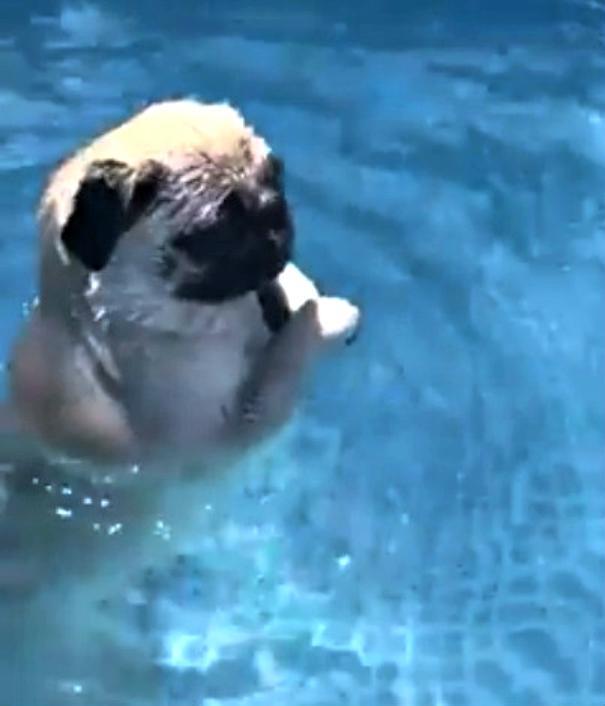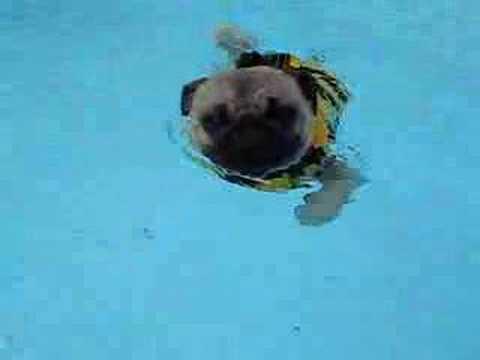The first image is the image on the left, the second image is the image on the right. Examine the images to the left and right. Is the description "An image shows a rightward facing dog in a pool with no flotation device." accurate? Answer yes or no. Yes. The first image is the image on the left, the second image is the image on the right. Assess this claim about the two images: "Two small dogs with pudgy noses and downturned ears are in a swimming pool aided by a floatation device.". Correct or not? Answer yes or no. No. 